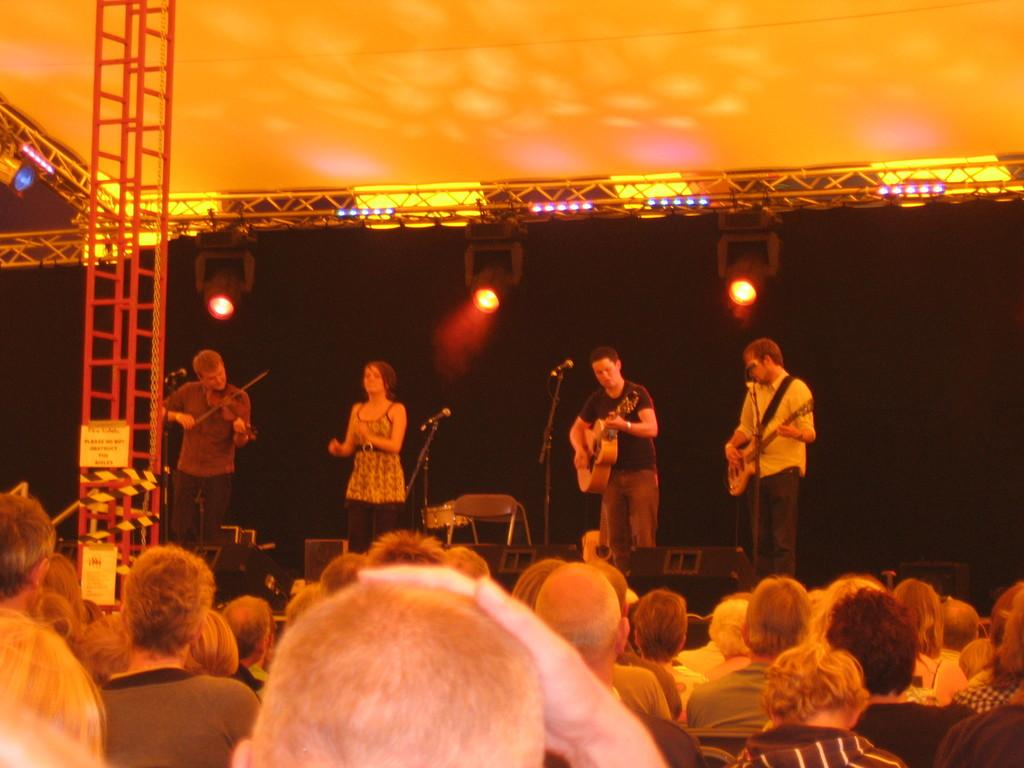What are the people on stage doing in the image? The people on stage are playing guitar. What is in front of the people on stage? There is a microphone in front of the people on stage. Who else is present in the image besides the people on stage? There are other people watching the performance. How many clocks are visible on the stage in the image? There are no clocks visible on the stage in the image. What type of knot is being tied by the person on stage? There is no person on stage tying a knot; they are playing guitar. 